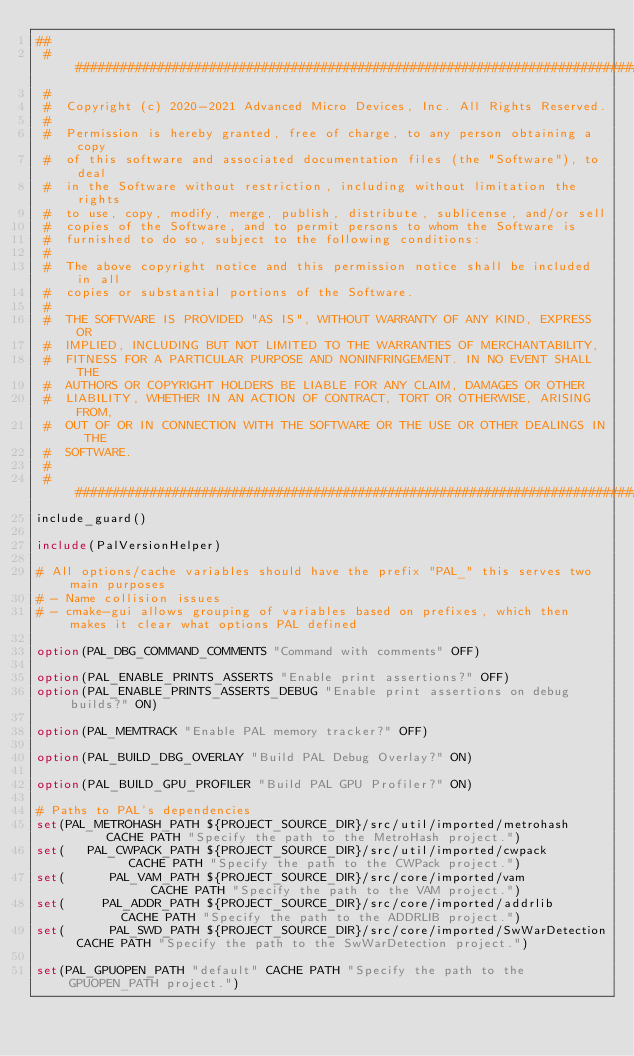Convert code to text. <code><loc_0><loc_0><loc_500><loc_500><_CMake_>##
 #######################################################################################################################
 #
 #  Copyright (c) 2020-2021 Advanced Micro Devices, Inc. All Rights Reserved.
 #
 #  Permission is hereby granted, free of charge, to any person obtaining a copy
 #  of this software and associated documentation files (the "Software"), to deal
 #  in the Software without restriction, including without limitation the rights
 #  to use, copy, modify, merge, publish, distribute, sublicense, and/or sell
 #  copies of the Software, and to permit persons to whom the Software is
 #  furnished to do so, subject to the following conditions:
 #
 #  The above copyright notice and this permission notice shall be included in all
 #  copies or substantial portions of the Software.
 #
 #  THE SOFTWARE IS PROVIDED "AS IS", WITHOUT WARRANTY OF ANY KIND, EXPRESS OR
 #  IMPLIED, INCLUDING BUT NOT LIMITED TO THE WARRANTIES OF MERCHANTABILITY,
 #  FITNESS FOR A PARTICULAR PURPOSE AND NONINFRINGEMENT. IN NO EVENT SHALL THE
 #  AUTHORS OR COPYRIGHT HOLDERS BE LIABLE FOR ANY CLAIM, DAMAGES OR OTHER
 #  LIABILITY, WHETHER IN AN ACTION OF CONTRACT, TORT OR OTHERWISE, ARISING FROM,
 #  OUT OF OR IN CONNECTION WITH THE SOFTWARE OR THE USE OR OTHER DEALINGS IN THE
 #  SOFTWARE.
 #
 #######################################################################################################################
include_guard()

include(PalVersionHelper)

# All options/cache variables should have the prefix "PAL_" this serves two main purposes
# - Name collision issues
# - cmake-gui allows grouping of variables based on prefixes, which then makes it clear what options PAL defined

option(PAL_DBG_COMMAND_COMMENTS "Command with comments" OFF)

option(PAL_ENABLE_PRINTS_ASSERTS "Enable print assertions?" OFF)
option(PAL_ENABLE_PRINTS_ASSERTS_DEBUG "Enable print assertions on debug builds?" ON)

option(PAL_MEMTRACK "Enable PAL memory tracker?" OFF)

option(PAL_BUILD_DBG_OVERLAY "Build PAL Debug Overlay?" ON)

option(PAL_BUILD_GPU_PROFILER "Build PAL GPU Profiler?" ON)

# Paths to PAL's dependencies
set(PAL_METROHASH_PATH ${PROJECT_SOURCE_DIR}/src/util/imported/metrohash      CACHE PATH "Specify the path to the MetroHash project.")
set(   PAL_CWPACK_PATH ${PROJECT_SOURCE_DIR}/src/util/imported/cwpack         CACHE PATH "Specify the path to the CWPack project.")
set(      PAL_VAM_PATH ${PROJECT_SOURCE_DIR}/src/core/imported/vam            CACHE PATH "Specify the path to the VAM project.")
set(     PAL_ADDR_PATH ${PROJECT_SOURCE_DIR}/src/core/imported/addrlib        CACHE PATH "Specify the path to the ADDRLIB project.")
set(      PAL_SWD_PATH ${PROJECT_SOURCE_DIR}/src/core/imported/SwWarDetection CACHE PATH "Specify the path to the SwWarDetection project.")

set(PAL_GPUOPEN_PATH "default" CACHE PATH "Specify the path to the GPUOPEN_PATH project.")

</code> 